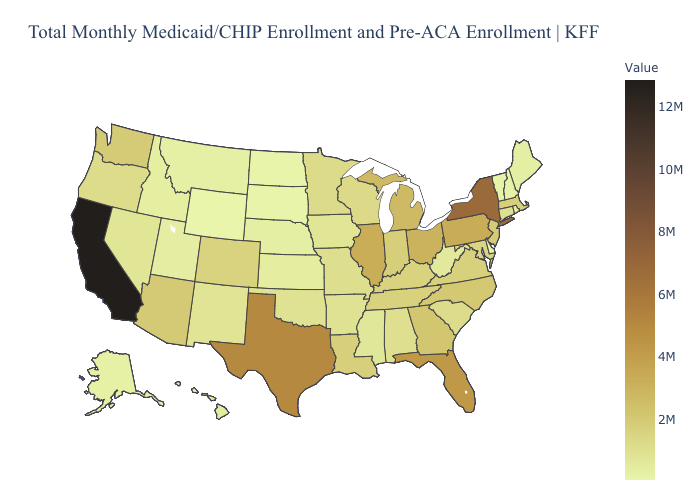Among the states that border Georgia , which have the highest value?
Short answer required. Florida. Among the states that border Louisiana , which have the lowest value?
Write a very short answer. Mississippi. Does Maryland have a lower value than Pennsylvania?
Short answer required. Yes. Does Arizona have a lower value than California?
Write a very short answer. Yes. Among the states that border Nebraska , which have the highest value?
Keep it brief. Colorado. 